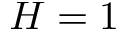<formula> <loc_0><loc_0><loc_500><loc_500>H = 1</formula> 